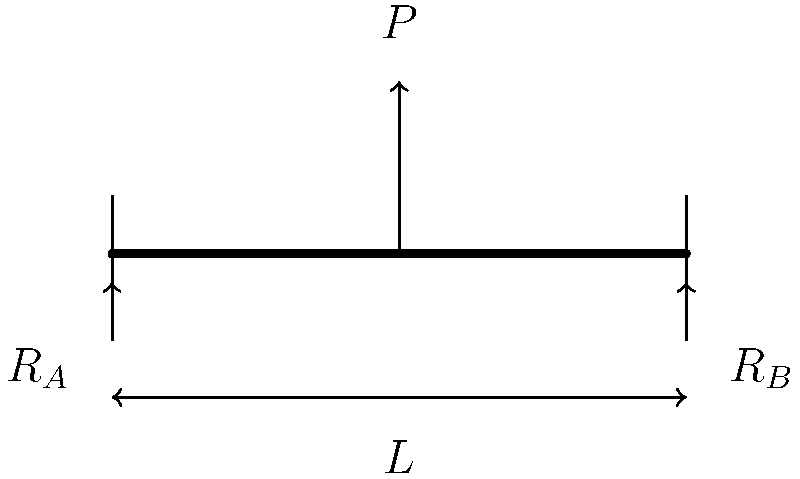As a field worker, you're tasked with assessing the safety of a temporary bridge structure in a disaster-affected area. The bridge span is $L$ meters long and is subjected to a point load $P$ at its midpoint. Using the free-body diagram provided, determine the reaction force $R_A$ at the left support in terms of $P$. To solve this problem, we'll use the principles of static equilibrium. Here's a step-by-step approach:

1) First, we need to consider the equilibrium conditions for the bridge:
   - Sum of forces in the vertical direction must be zero
   - Sum of moments about any point must be zero

2) Let's sum the forces in the vertical direction:
   $$R_A + R_B - P = 0$$

3) Now, let's sum the moments about point A (the left support):
   $$R_B \cdot L - P \cdot \frac{L}{2} = 0$$

4) From the moment equation, we can solve for $R_B$:
   $$R_B = \frac{P \cdot \frac{L}{2}}{L} = \frac{P}{2}$$

5) Substituting this back into the force equation:
   $$R_A + \frac{P}{2} - P = 0$$

6) Solving for $R_A$:
   $$R_A = P - \frac{P}{2} = \frac{P}{2}$$

Therefore, the reaction force at the left support, $R_A$, is equal to half of the applied load $P$.
Answer: $R_A = \frac{P}{2}$ 